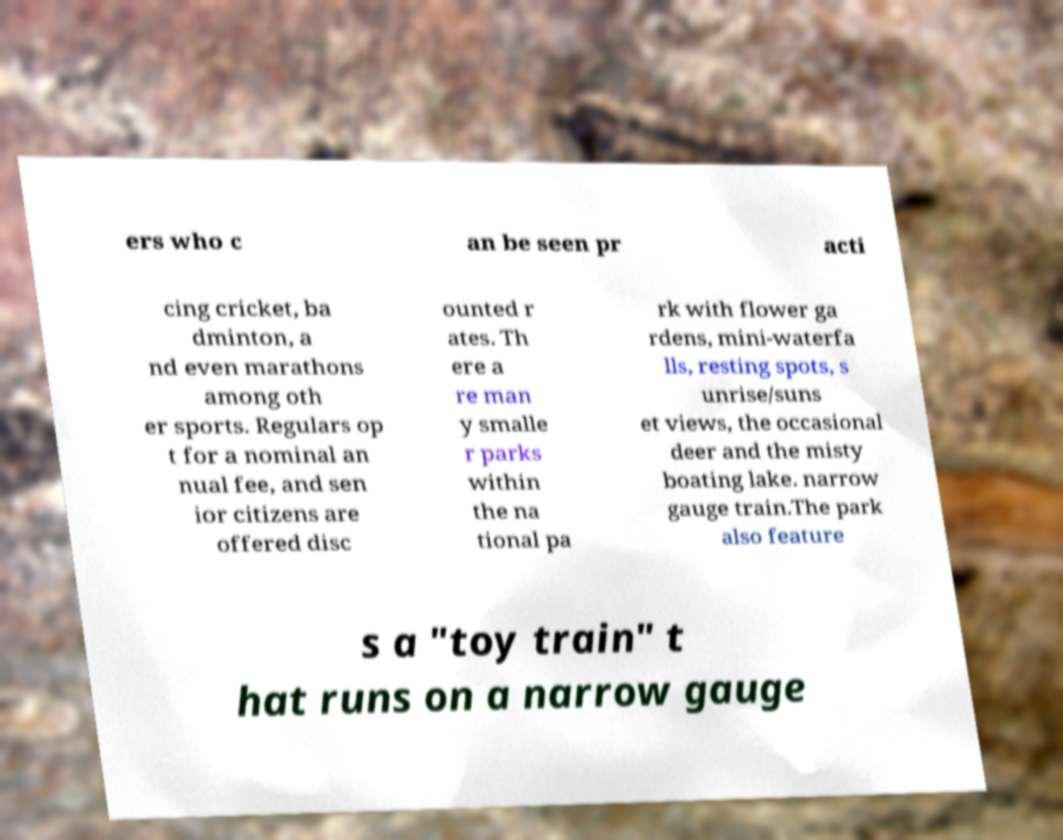I need the written content from this picture converted into text. Can you do that? ers who c an be seen pr acti cing cricket, ba dminton, a nd even marathons among oth er sports. Regulars op t for a nominal an nual fee, and sen ior citizens are offered disc ounted r ates. Th ere a re man y smalle r parks within the na tional pa rk with flower ga rdens, mini-waterfa lls, resting spots, s unrise/suns et views, the occasional deer and the misty boating lake. narrow gauge train.The park also feature s a "toy train" t hat runs on a narrow gauge 